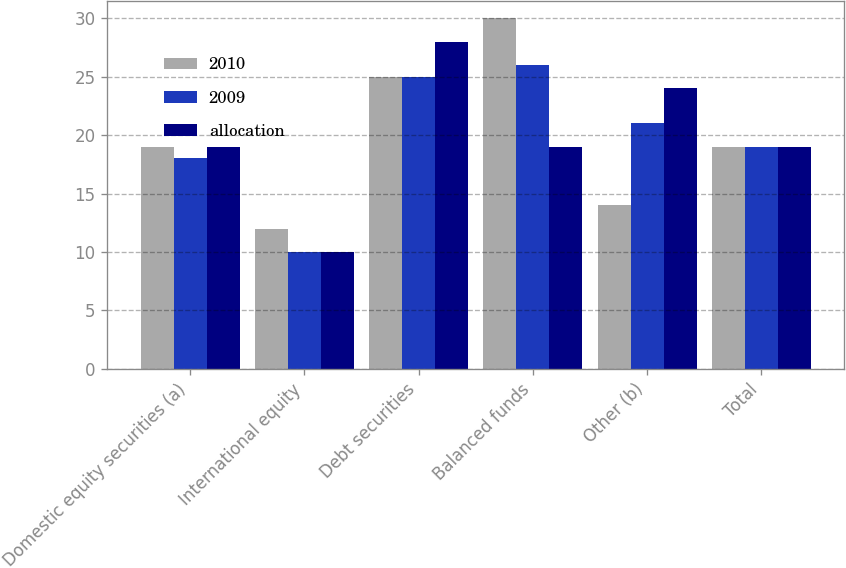Convert chart to OTSL. <chart><loc_0><loc_0><loc_500><loc_500><stacked_bar_chart><ecel><fcel>Domestic equity securities (a)<fcel>International equity<fcel>Debt securities<fcel>Balanced funds<fcel>Other (b)<fcel>Total<nl><fcel>2010<fcel>19<fcel>12<fcel>25<fcel>30<fcel>14<fcel>19<nl><fcel>2009<fcel>18<fcel>10<fcel>25<fcel>26<fcel>21<fcel>19<nl><fcel>allocation<fcel>19<fcel>10<fcel>28<fcel>19<fcel>24<fcel>19<nl></chart> 